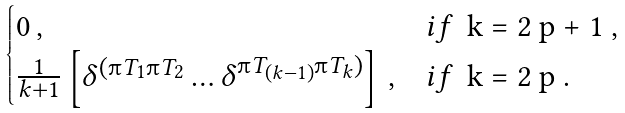<formula> <loc_0><loc_0><loc_500><loc_500>\begin{cases} 0 \, , & i f \, $ k = 2 p + 1 $ , \\ \frac { 1 } { k + 1 } \left [ \delta ^ { ( \i T _ { 1 } \i T _ { 2 } } \dots \delta ^ { \i T _ { ( k - 1 ) } \i T _ { k } ) } \right ] \, , & i f \, $ k = 2 p $ . \end{cases}</formula> 